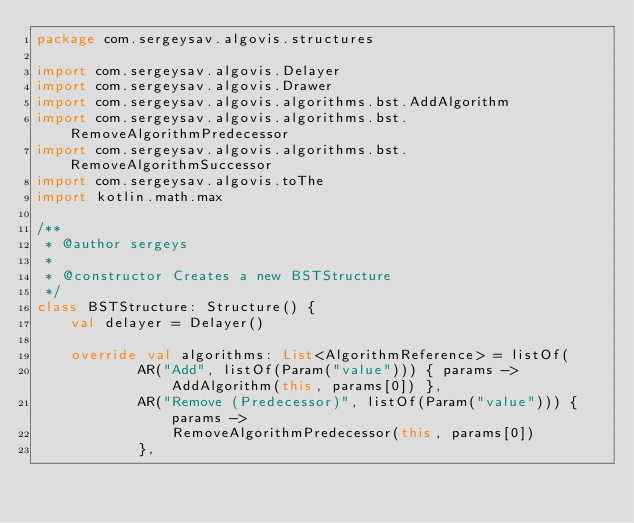<code> <loc_0><loc_0><loc_500><loc_500><_Kotlin_>package com.sergeysav.algovis.structures

import com.sergeysav.algovis.Delayer
import com.sergeysav.algovis.Drawer
import com.sergeysav.algovis.algorithms.bst.AddAlgorithm
import com.sergeysav.algovis.algorithms.bst.RemoveAlgorithmPredecessor
import com.sergeysav.algovis.algorithms.bst.RemoveAlgorithmSuccessor
import com.sergeysav.algovis.toThe
import kotlin.math.max

/**
 * @author sergeys
 *
 * @constructor Creates a new BSTStructure
 */
class BSTStructure: Structure() {
    val delayer = Delayer()
    
    override val algorithms: List<AlgorithmReference> = listOf(
            AR("Add", listOf(Param("value"))) { params -> AddAlgorithm(this, params[0]) },
            AR("Remove (Predecessor)", listOf(Param("value"))) { params ->
                RemoveAlgorithmPredecessor(this, params[0])
            },</code> 